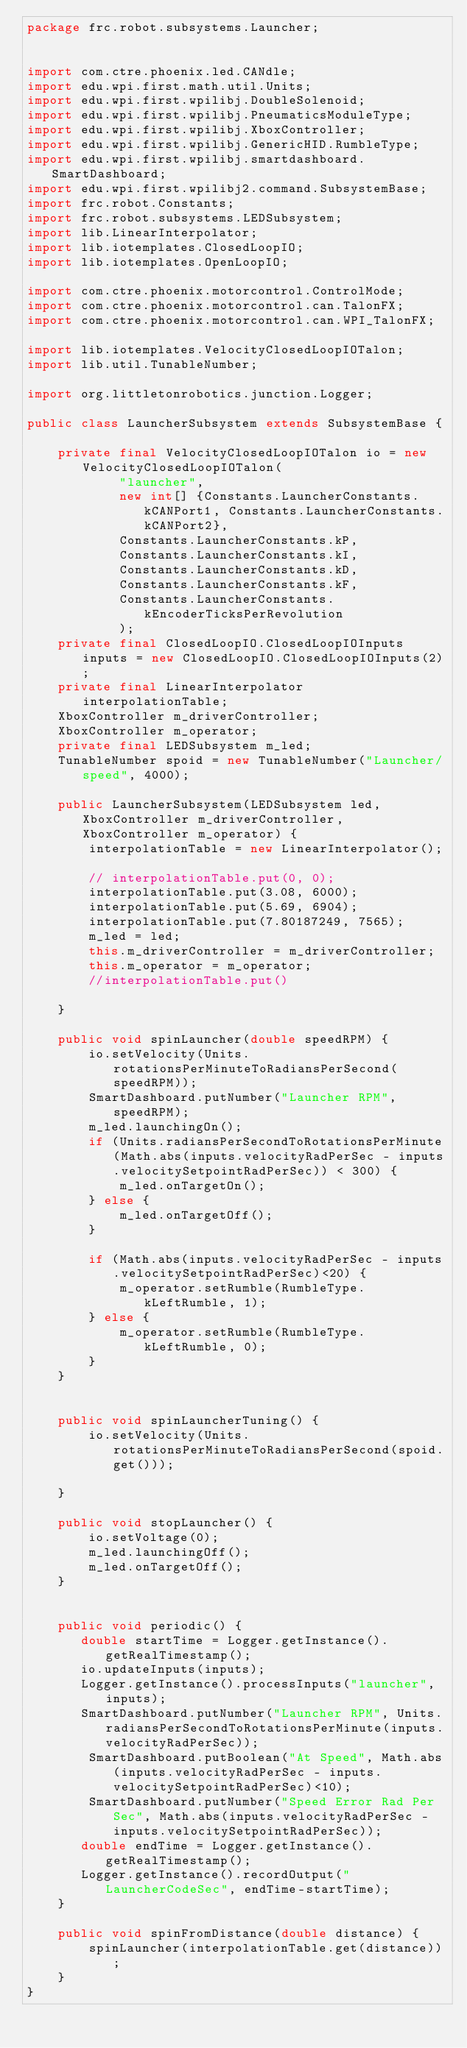Convert code to text. <code><loc_0><loc_0><loc_500><loc_500><_Java_>package frc.robot.subsystems.Launcher;


import com.ctre.phoenix.led.CANdle;
import edu.wpi.first.math.util.Units;
import edu.wpi.first.wpilibj.DoubleSolenoid;
import edu.wpi.first.wpilibj.PneumaticsModuleType;
import edu.wpi.first.wpilibj.XboxController;
import edu.wpi.first.wpilibj.GenericHID.RumbleType;
import edu.wpi.first.wpilibj.smartdashboard.SmartDashboard;
import edu.wpi.first.wpilibj2.command.SubsystemBase;
import frc.robot.Constants;
import frc.robot.subsystems.LEDSubsystem;
import lib.LinearInterpolator;
import lib.iotemplates.ClosedLoopIO;
import lib.iotemplates.OpenLoopIO;

import com.ctre.phoenix.motorcontrol.ControlMode;
import com.ctre.phoenix.motorcontrol.can.TalonFX;
import com.ctre.phoenix.motorcontrol.can.WPI_TalonFX;

import lib.iotemplates.VelocityClosedLoopIOTalon;
import lib.util.TunableNumber;

import org.littletonrobotics.junction.Logger;

public class LauncherSubsystem extends SubsystemBase {

    private final VelocityClosedLoopIOTalon io = new VelocityClosedLoopIOTalon(
            "launcher",
            new int[] {Constants.LauncherConstants.kCANPort1, Constants.LauncherConstants.kCANPort2},
            Constants.LauncherConstants.kP,
            Constants.LauncherConstants.kI,
            Constants.LauncherConstants.kD,
            Constants.LauncherConstants.kF,
            Constants.LauncherConstants.kEncoderTicksPerRevolution
            );
    private final ClosedLoopIO.ClosedLoopIOInputs inputs = new ClosedLoopIO.ClosedLoopIOInputs(2);
    private final LinearInterpolator interpolationTable;
    XboxController m_driverController;
    XboxController m_operator;
    private final LEDSubsystem m_led;
    TunableNumber spoid = new TunableNumber("Launcher/speed", 4000);

    public LauncherSubsystem(LEDSubsystem led, XboxController m_driverController, XboxController m_operator) {
        interpolationTable = new LinearInterpolator();

        // interpolationTable.put(0, 0);
        interpolationTable.put(3.08, 6000);
        interpolationTable.put(5.69, 6904);
        interpolationTable.put(7.80187249, 7565);
        m_led = led;
        this.m_driverController = m_driverController;
        this.m_operator = m_operator;
        //interpolationTable.put()
        
    }

    public void spinLauncher(double speedRPM) {
        io.setVelocity(Units.rotationsPerMinuteToRadiansPerSecond(speedRPM));
        SmartDashboard.putNumber("Launcher RPM", speedRPM);
        m_led.launchingOn();
        if (Units.radiansPerSecondToRotationsPerMinute(Math.abs(inputs.velocityRadPerSec - inputs.velocitySetpointRadPerSec)) < 300) {
            m_led.onTargetOn();
        } else {
            m_led.onTargetOff();
        }

        if (Math.abs(inputs.velocityRadPerSec - inputs.velocitySetpointRadPerSec)<20) {
            m_operator.setRumble(RumbleType.kLeftRumble, 1);
        } else {
            m_operator.setRumble(RumbleType.kLeftRumble, 0);
        }
    }


    public void spinLauncherTuning() {
        io.setVelocity(Units.rotationsPerMinuteToRadiansPerSecond(spoid.get()));
       
    }

    public void stopLauncher() {
        io.setVoltage(0);
        m_led.launchingOff();
        m_led.onTargetOff();
    }


    public void periodic() {
       double startTime = Logger.getInstance().getRealTimestamp();
       io.updateInputs(inputs);
       Logger.getInstance().processInputs("launcher", inputs);
       SmartDashboard.putNumber("Launcher RPM", Units.radiansPerSecondToRotationsPerMinute(inputs.velocityRadPerSec));
        SmartDashboard.putBoolean("At Speed", Math.abs(inputs.velocityRadPerSec - inputs.velocitySetpointRadPerSec)<10);
        SmartDashboard.putNumber("Speed Error Rad Per Sec", Math.abs(inputs.velocityRadPerSec - inputs.velocitySetpointRadPerSec));
       double endTime = Logger.getInstance().getRealTimestamp();
       Logger.getInstance().recordOutput("LauncherCodeSec", endTime-startTime);
    }

    public void spinFromDistance(double distance) {
        spinLauncher(interpolationTable.get(distance));
    }
}

</code> 